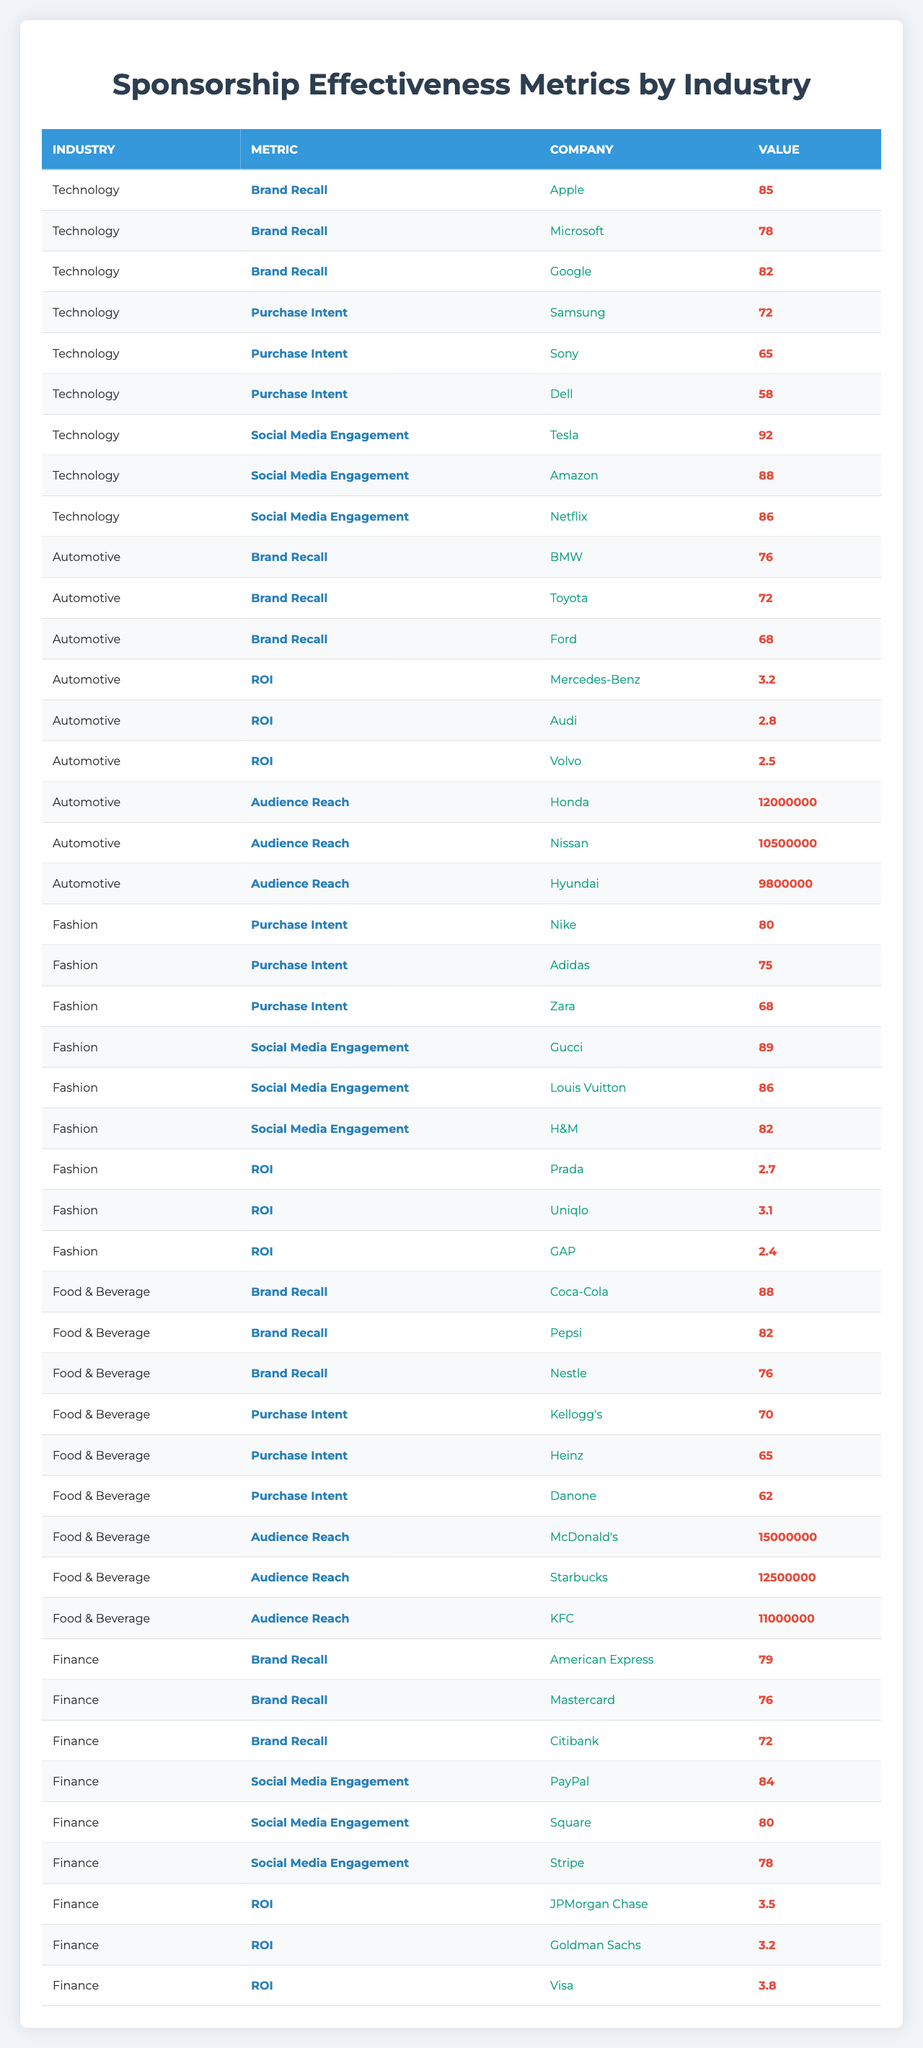What is the highest brand recall percentage in the Technology sector? Looking at the Technology sector, the brand recall percentages for Apple, Microsoft, and Google are 85, 78, and 82, respectively. The highest value is 85, which belongs to Apple.
Answer: 85 Which company has the highest audience reach in the Automotive sector? In the Automotive sector, the audience reach values for Honda, Nissan, and Hyundai are 12,000,000, 10,500,000, and 9,800,000. The highest audience reach is for Honda with 12,000,000.
Answer: Honda What is the average purchase intent from the Fashion sector? The purchase intent values in the Fashion sector are for Nike (80), Adidas (75), and Zara (68). Adding these values gives 80 + 75 + 68 = 223. Dividing by 3 gives an average purchase intent of 223/3 ≈ 74.33.
Answer: 74.33 Is Tesla the company with the highest social media engagement in the Technology sector? In the Technology sector, Tesla has a social media engagement of 92, while Amazon has 88 and Netflix has 86. Since 92 is higher than both, Tesla does have the highest engagement.
Answer: Yes What is the difference between the highest and lowest ROI in the Automotive sector? The ROI values for the Automotive sector are 3.2 for Mercedes-Benz, 2.8 for Audi, and 2.5 for Volvo. The difference is calculated as 3.2 (highest) - 2.5 (lowest) = 0.7.
Answer: 0.7 Which sector has the highest average brand recall? The brand recall values are as follows: Technology has 85, 78, 82; Automotive has 76, 72, 68; Food & Beverage has 88, 82, 76; Finance has 79, 76, 72. Calculating each sector's average, Technology ≈ 81.67, Automotive ≈ 72, Food & Beverage ≈ 82, Finance ≈ 75.67. Food & Beverage has the highest average brand recall with 82.
Answer: Food & Beverage Is there any company in the Finance sector with a social media engagement below 80? The social media engagement values for the Finance sector are PayPal (84), Square (80), and Stripe (78). Since Stripe has a value lower than 80, there is a company in that sector with lower engagement.
Answer: Yes What is the total brand recall from the Food & Beverage sector? In the Food & Beverage sector, the brand recall values are 88 (Coca-Cola), 82 (Pepsi), and 76 (Nestle). Adding these values gives 88 + 82 + 76 = 246.
Answer: 246 Which company from the Fashion sector has the lowest ROI? The ROI values in the Fashion sector are 2.7 for Prada, 3.1 for Uniqlo, and 2.4 for GAP. Since 2.4 is the lowest value, GAP has the lowest ROI.
Answer: GAP What is the highest purchase intent among the companies listed in the Food & Beverage sector? The purchase intent values in the Food & Beverage sector are Kellogg's (70), Heinz (65), and Danone (62). The highest value is for Kellogg's with 70.
Answer: Kellogg's 